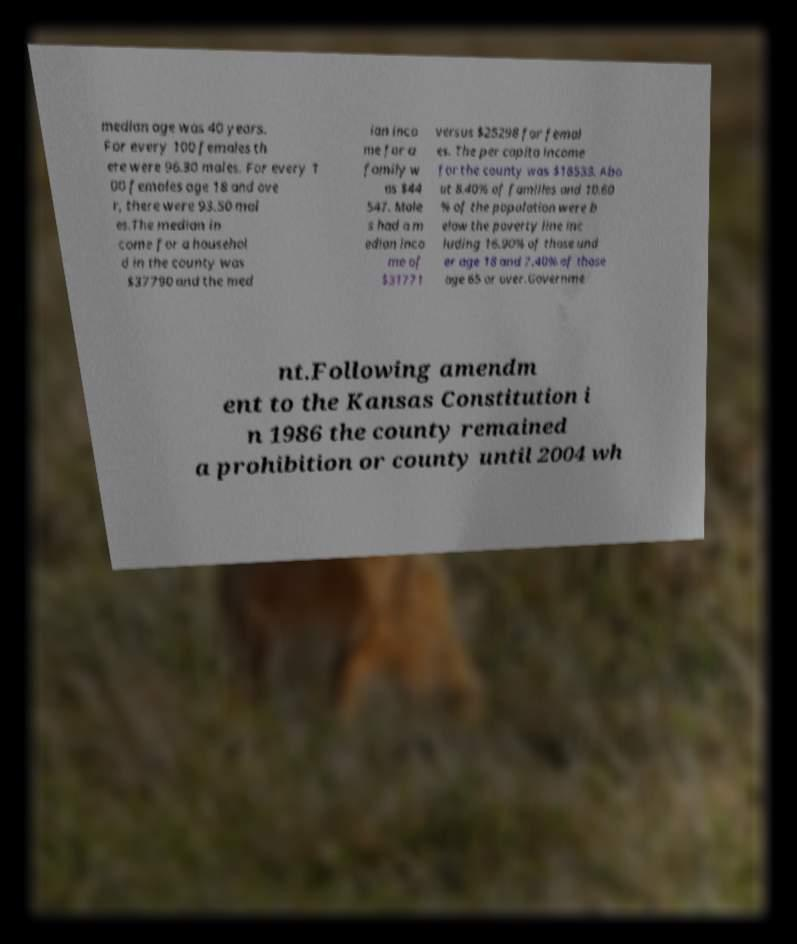There's text embedded in this image that I need extracted. Can you transcribe it verbatim? median age was 40 years. For every 100 females th ere were 96.30 males. For every 1 00 females age 18 and ove r, there were 93.50 mal es.The median in come for a househol d in the county was $37790 and the med ian inco me for a family w as $44 547. Male s had a m edian inco me of $31771 versus $25298 for femal es. The per capita income for the county was $18533. Abo ut 8.40% of families and 10.60 % of the population were b elow the poverty line inc luding 16.90% of those und er age 18 and 7.40% of those age 65 or over.Governme nt.Following amendm ent to the Kansas Constitution i n 1986 the county remained a prohibition or county until 2004 wh 